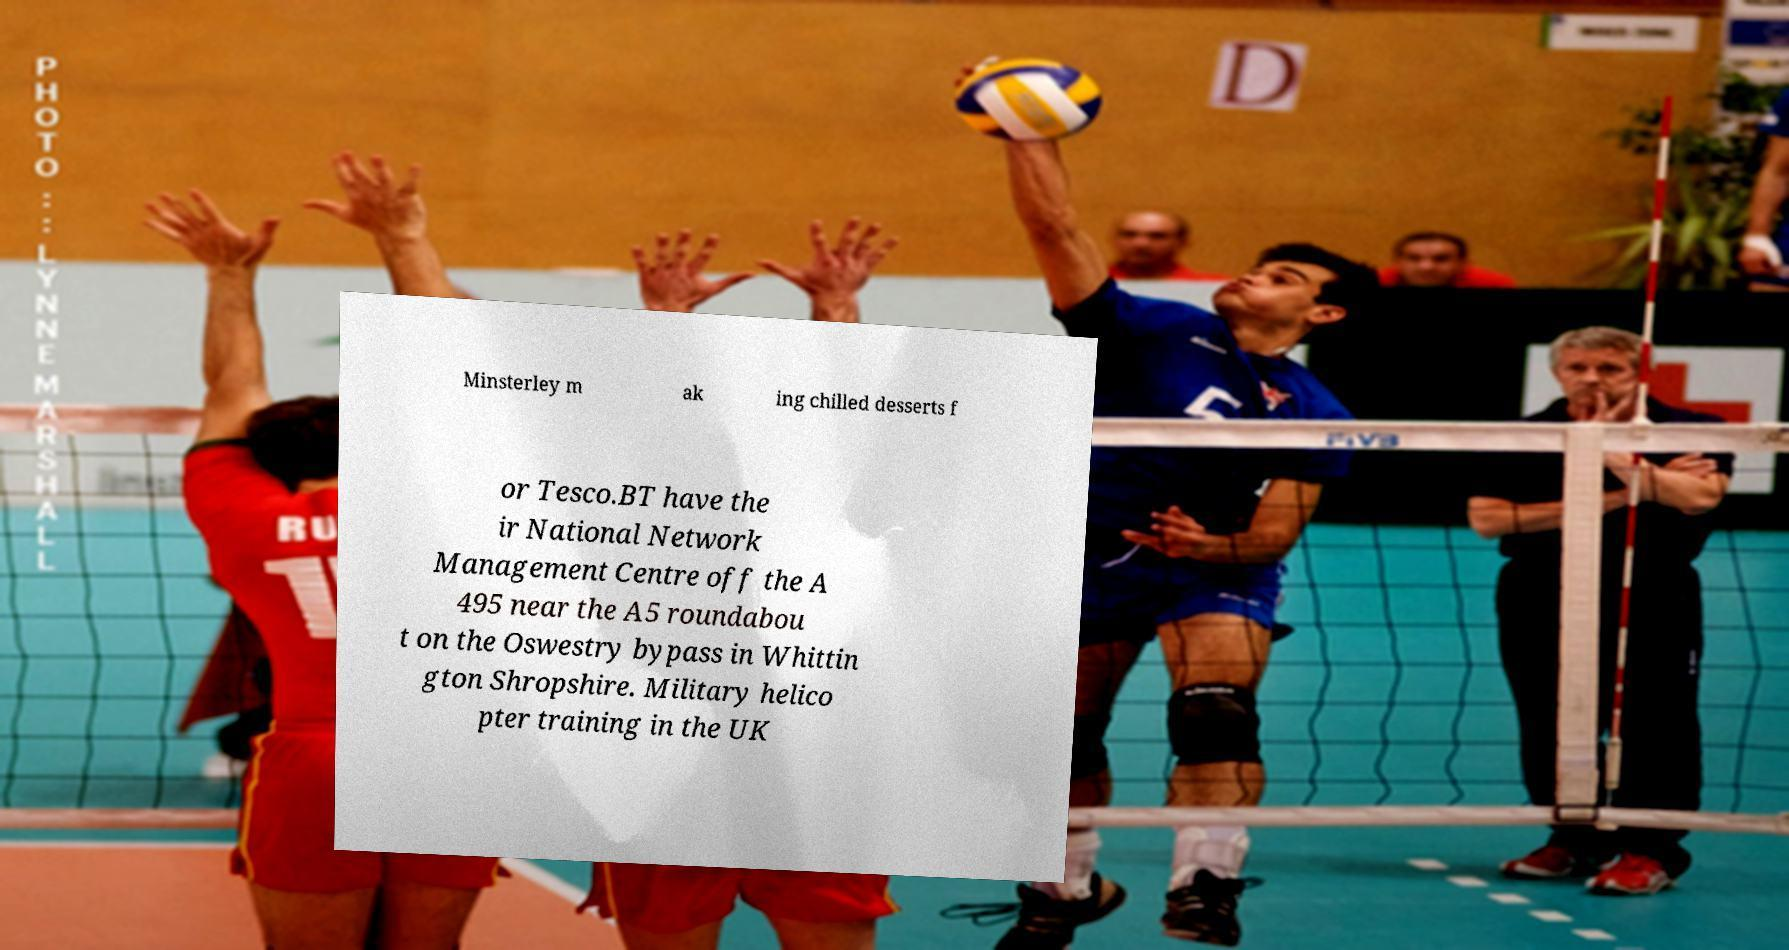Could you extract and type out the text from this image? Minsterley m ak ing chilled desserts f or Tesco.BT have the ir National Network Management Centre off the A 495 near the A5 roundabou t on the Oswestry bypass in Whittin gton Shropshire. Military helico pter training in the UK 